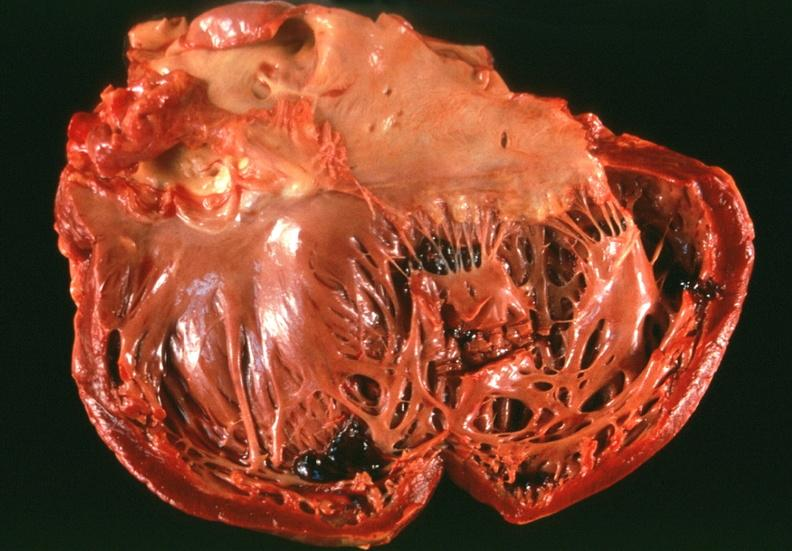does this image show congestive heart failure?
Answer the question using a single word or phrase. Yes 